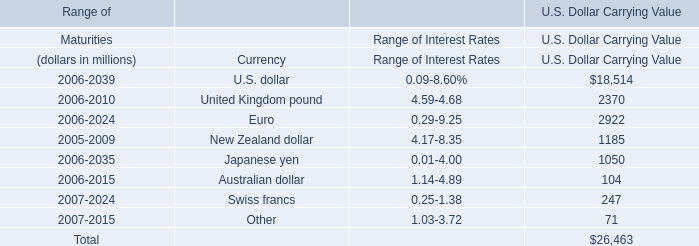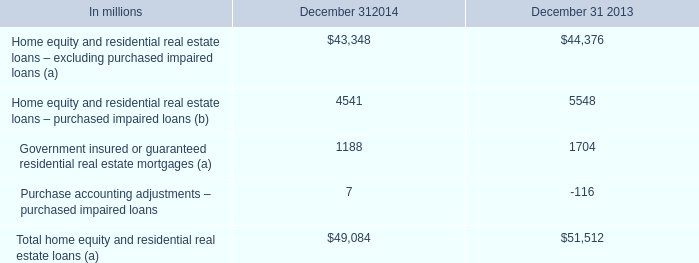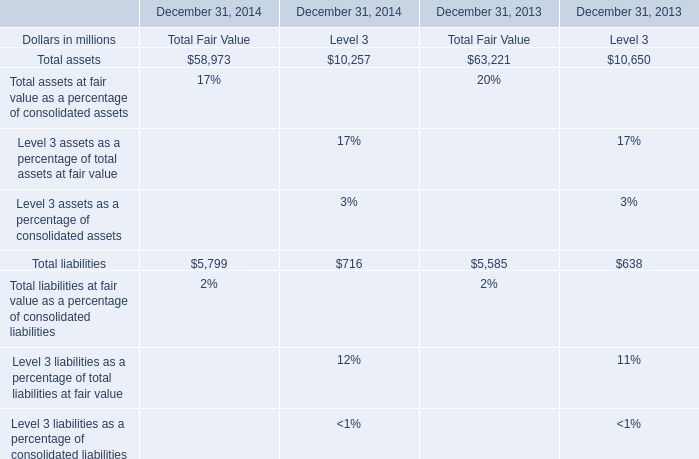In what sections is Total assets greater than 11000? 
Answer: Total Fair Value. 